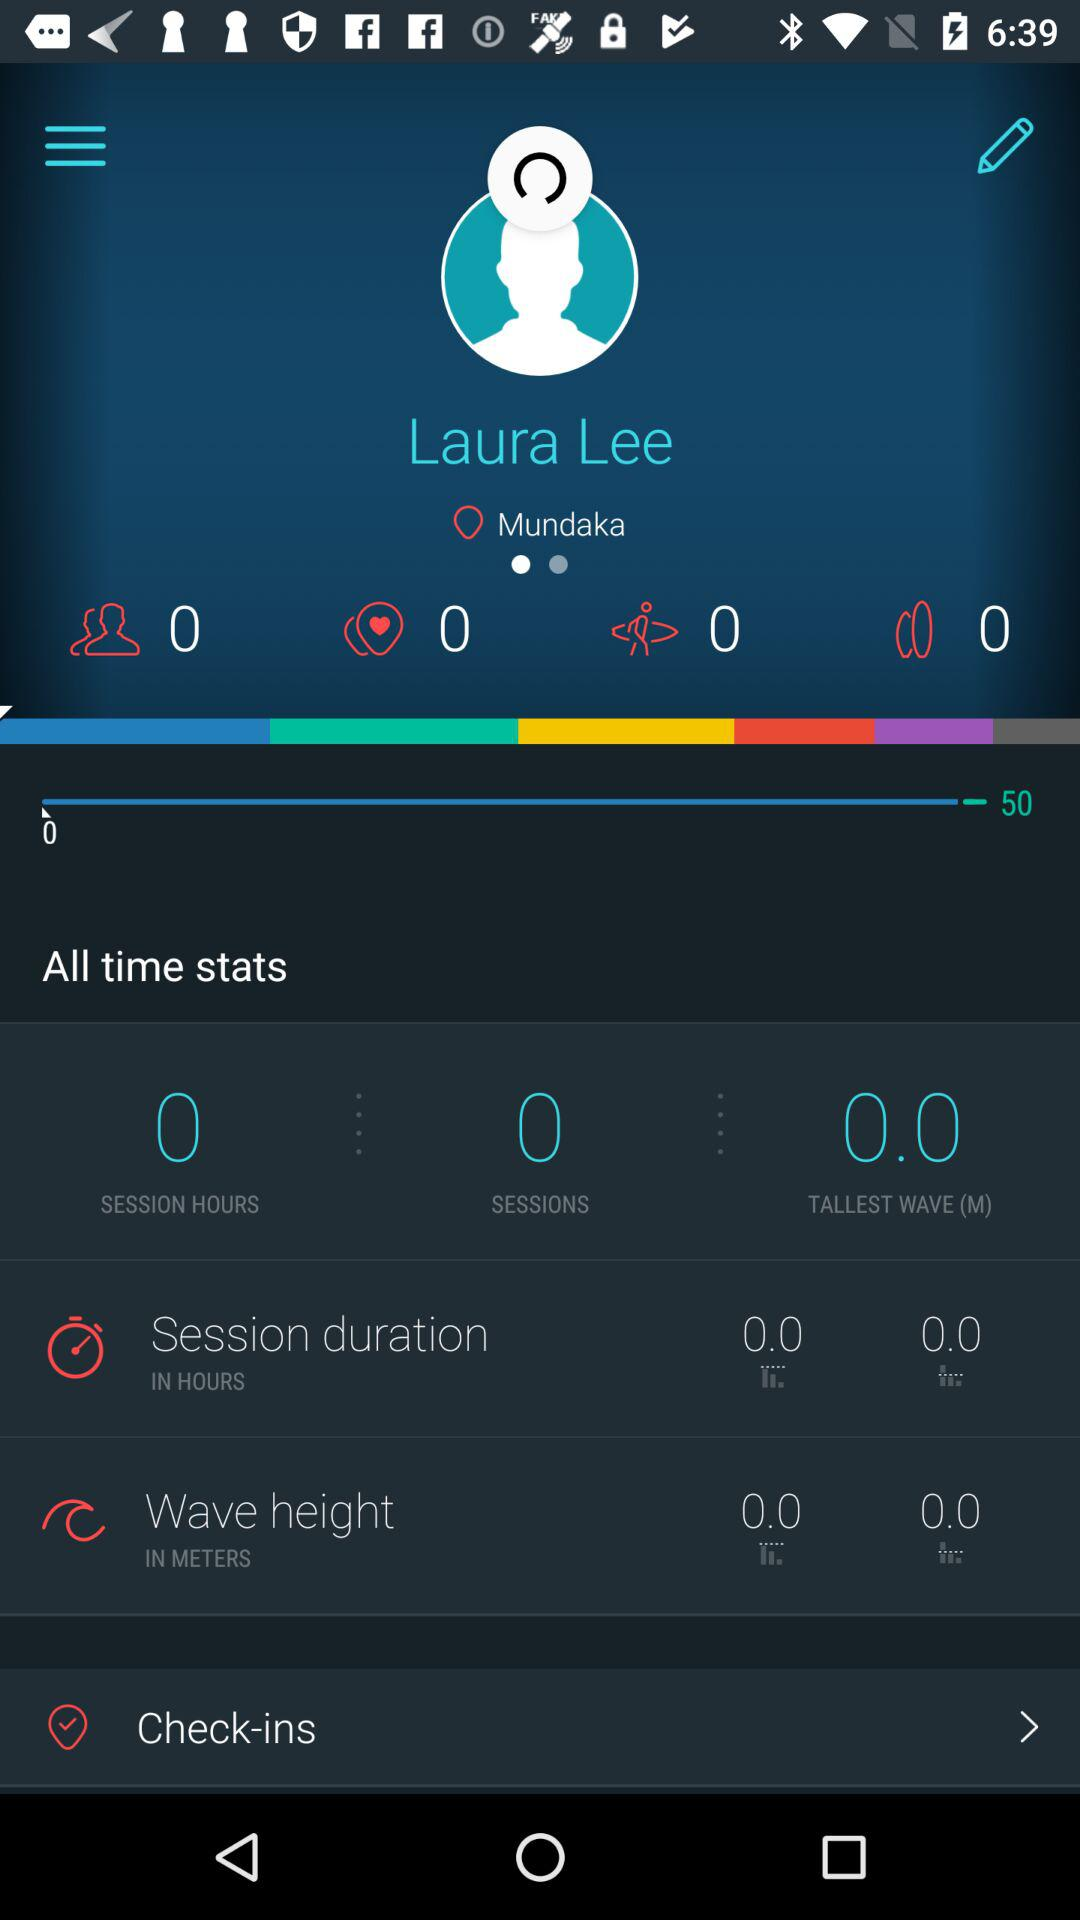What is the session duration? The session duration is 0. 